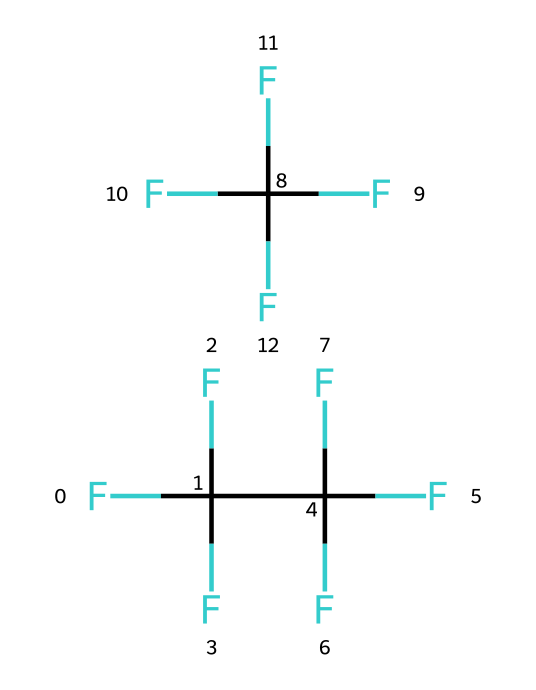What is the molecular formula of R-410A? To determine the molecular formula, we look at the SMILES representation, which shows both components of R-410A. The first part FC(F)(F)C(F)(F)F indicates a molecule with carbon (C) and fluorine (F) atoms. Counting the atoms gives us a total of 8 fluorine atoms and 2 carbon atoms from the two components combined. The overall formula is C2H2F10.
Answer: C2H2F10 How many carbon atoms are present in R-410A? In the SMILES representation, we can identify the number of carbon (C) atoms directly. There are 2 carbon atoms present in the first part of the molecule FC(F)(F)C(F)(F)F. The second component does not add any additional carbon atoms.
Answer: 2 What type of bonding is predominant in R-410A? The predominant type of bonding in R-410A is covalent bonding, which can be inferred from the arrangement of the atoms and the presence of hydrogen and fluorine atoms bonded to carbon. These atoms share electrons, indicating covalent bonds.
Answer: covalent What components make up R-410A? R-410A is made up of two binary compounds: one part contains a carbon atom attached to three fluorine atoms and another carbon- fluorine combination. This configuration reveals that R-410A consists of two different refrigerant compounds in a blend.
Answer: two fluorocarbon compounds What are the primary uses of R-410A? R-410A is primarily used as a refrigerant in air conditioning systems. Its chemical properties allow it to efficiently absorb and release heat, making it suitable for cooling applications in residential and commercial systems.
Answer: air conditioning systems Why is R-410A preferred over older refrigerants? R-410A is preferred due to its higher energy efficiency and lower ozone depletion potential compared to older refrigerants like R-22. The design of R-410A minimizes environmental impact, making it a more responsible choice in modern refrigeration technology.
Answer: lower environmental impact What impact does R-410A have on global warming? R-410A has a relatively high global warming potential (GWP) due to the carbon-fluorine bonds that can trap heat. Despite being more environmentally friendly than older refrigerants, its contribution to global warming is still a consideration in its use.
Answer: contributes to global warming 